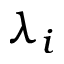Convert formula to latex. <formula><loc_0><loc_0><loc_500><loc_500>\lambda _ { i }</formula> 